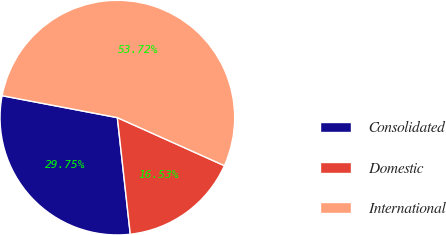Convert chart to OTSL. <chart><loc_0><loc_0><loc_500><loc_500><pie_chart><fcel>Consolidated<fcel>Domestic<fcel>International<nl><fcel>29.75%<fcel>16.53%<fcel>53.72%<nl></chart> 